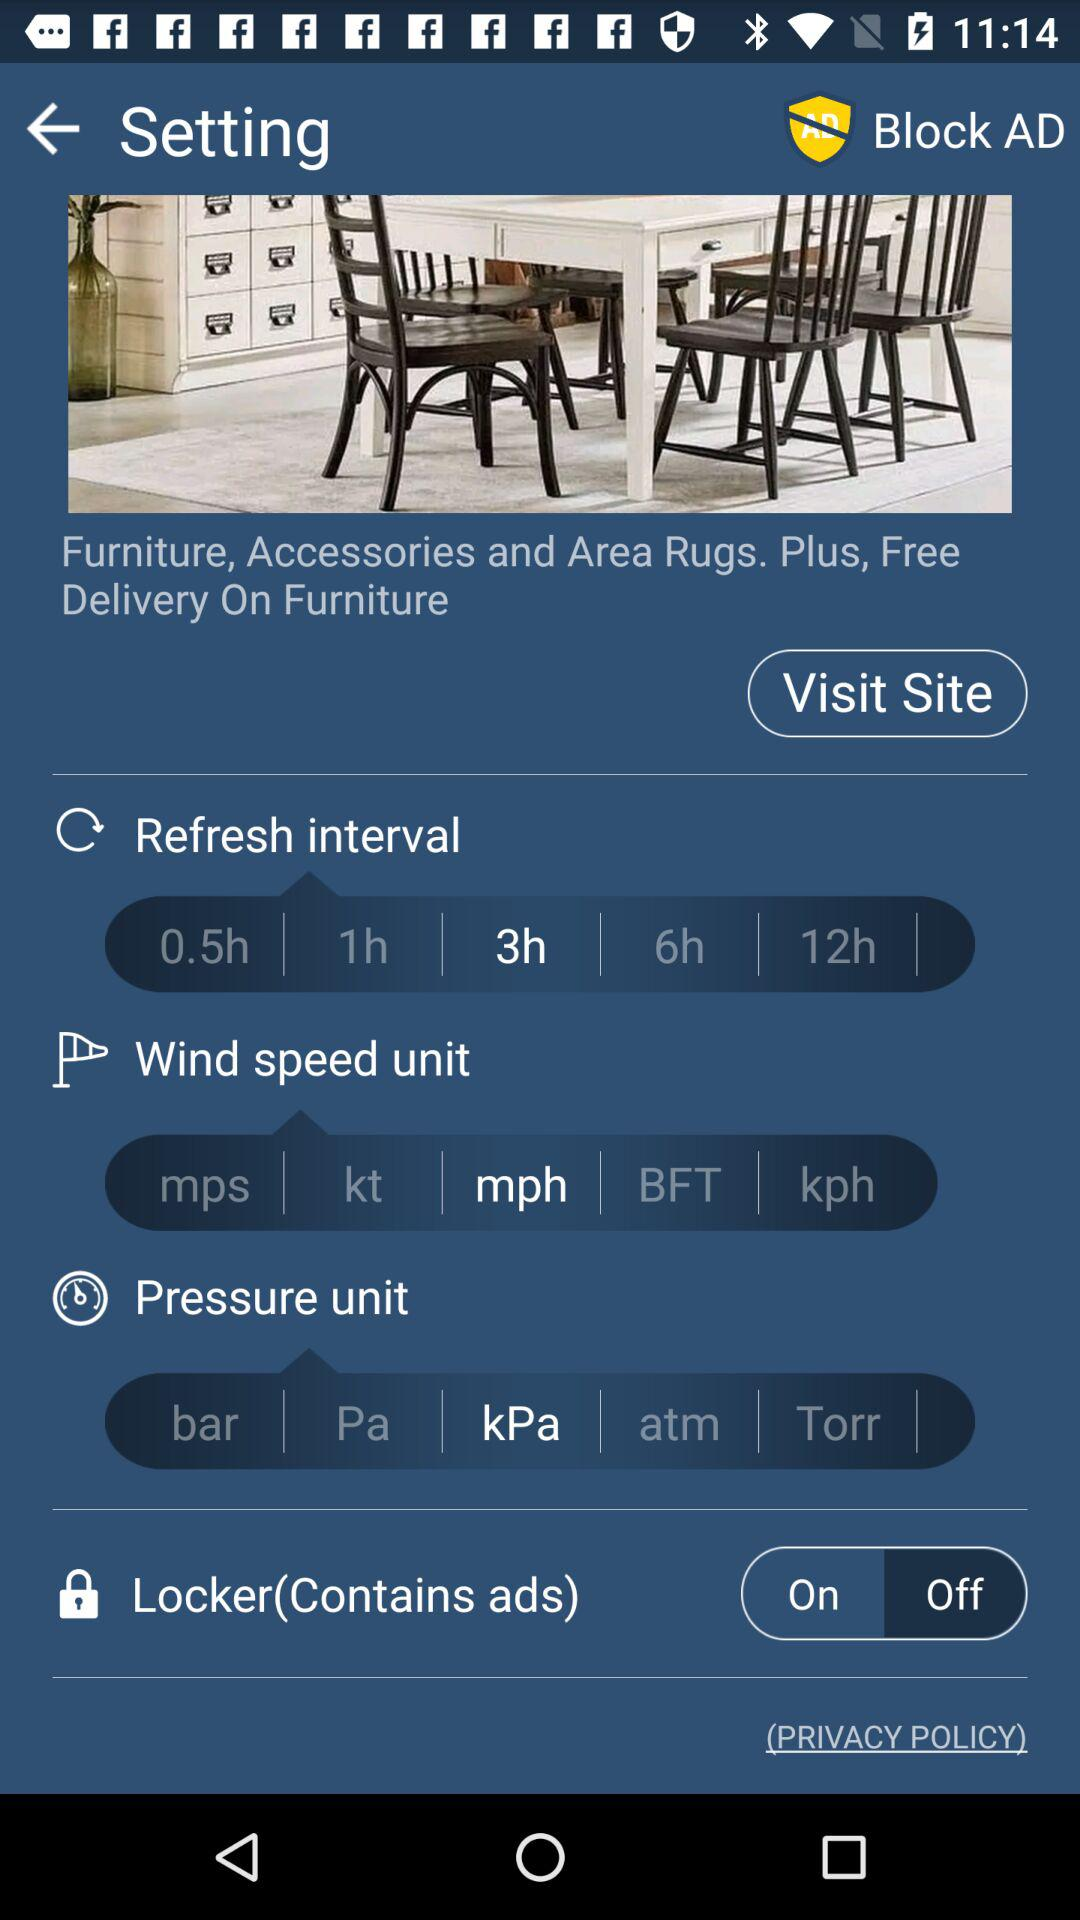Which is the selected pressure unit? The selected pressure unit is "kPa". 